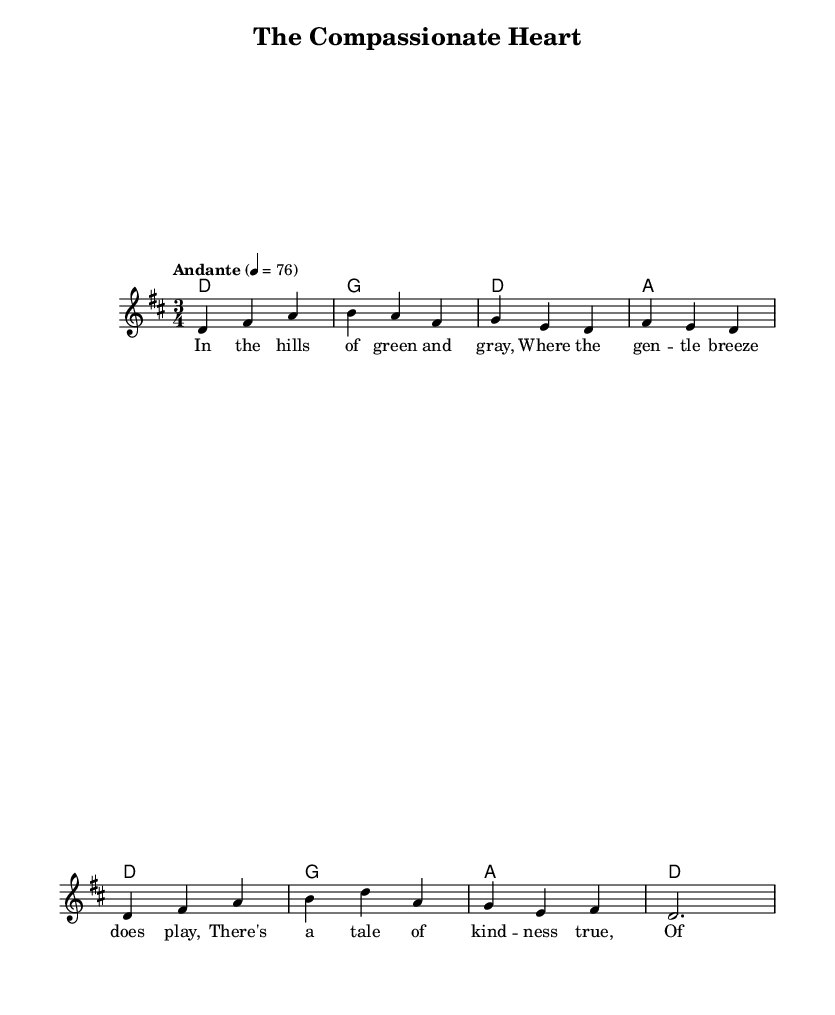What is the key signature of this music? The key signature is associated with the key of D major, which has two sharps (F sharp and C sharp). This can be determined from the markings at the beginning of the score.
Answer: D major What is the time signature of this music? The time signature shown in the sheet music is at the beginning of the score, which indicates it is composed in a 3/4 meter. This means there are three beats in each measure, and the quarter note gets one beat.
Answer: 3/4 What is the tempo marking for this piece? The tempo indication, placed above the music, states "Andante" with a metronome marking of 76. This indicates a moderately slow pace for the performance of the piece.
Answer: Andante 4 = 76 How many measures are in the melody? To find the number of measures, we count the distinct vertical bar lines in the melody staff. Each section is separated by a bar line, and upon counting, we see there are a total of 8 measures.
Answer: 8 What thematic element does the verse convey? The lyrics of the verse illustrate themes of kindness and strength. By analyzing the text, we see it expresses compassion through storytelling rooted in a natural setting.
Answer: Kindness What is the structure of the harmony in this piece? The harmonies provided show a clear progression between D major and its related harmonies. Examining the chord changes, we see a typical folk structure that supports the melody in a simple way.
Answer: D - G - A What kind of folk tradition does this music represent? The use of lyrical storytelling and simple melodic lines reflects a traditional Celtic folk ballad style, often centered around themes of empathy and human connection in a pastoral setting.
Answer: Celtic folk ballad 